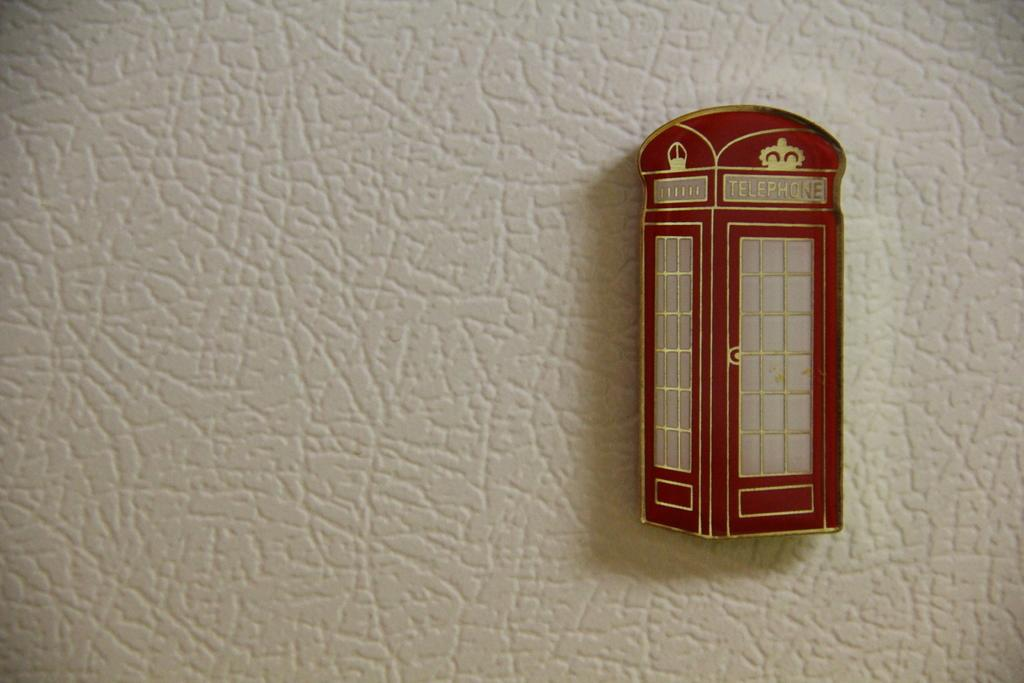Where was the image taken? The image is taken indoors. What can be seen in the middle of the image? There is a wall in the middle of the image. What is located on the right side of the image? There is a telephone booth on the right side of the image. What type of business is being conducted in the image? There is no indication of a business being conducted in the image; it primarily features a wall and a telephone booth. What news event is being discussed in the image? There is no news event being discussed in the image; it primarily features a wall and a telephone booth. 